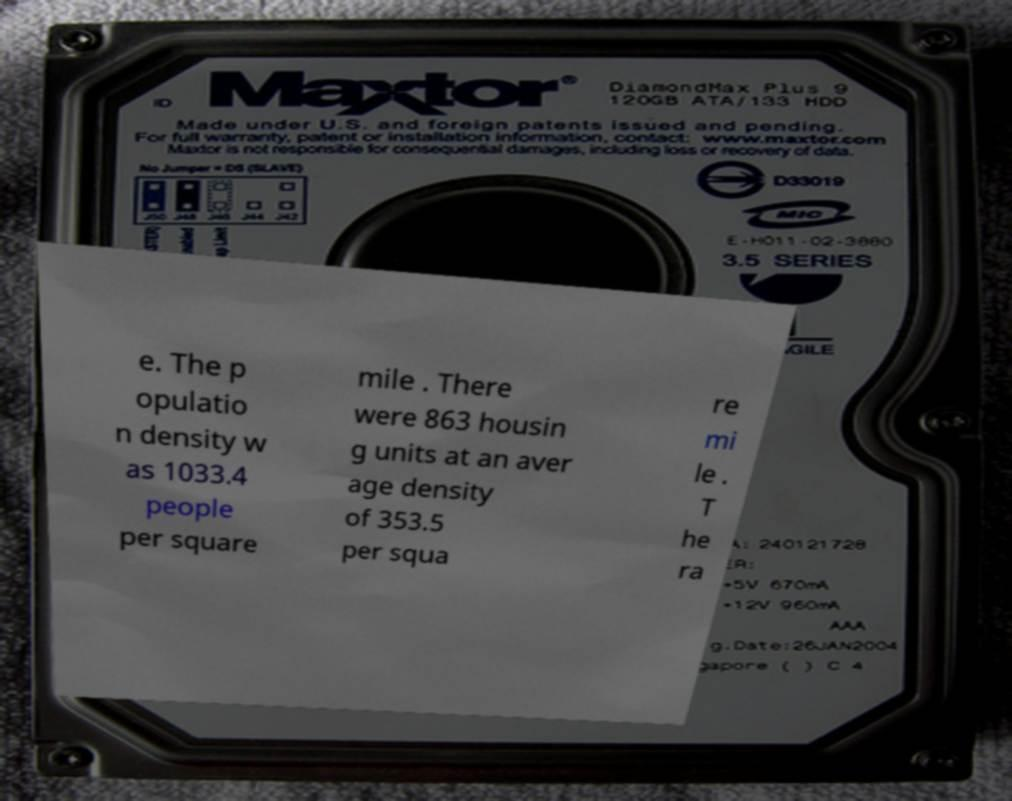Can you accurately transcribe the text from the provided image for me? e. The p opulatio n density w as 1033.4 people per square mile . There were 863 housin g units at an aver age density of 353.5 per squa re mi le . T he ra 